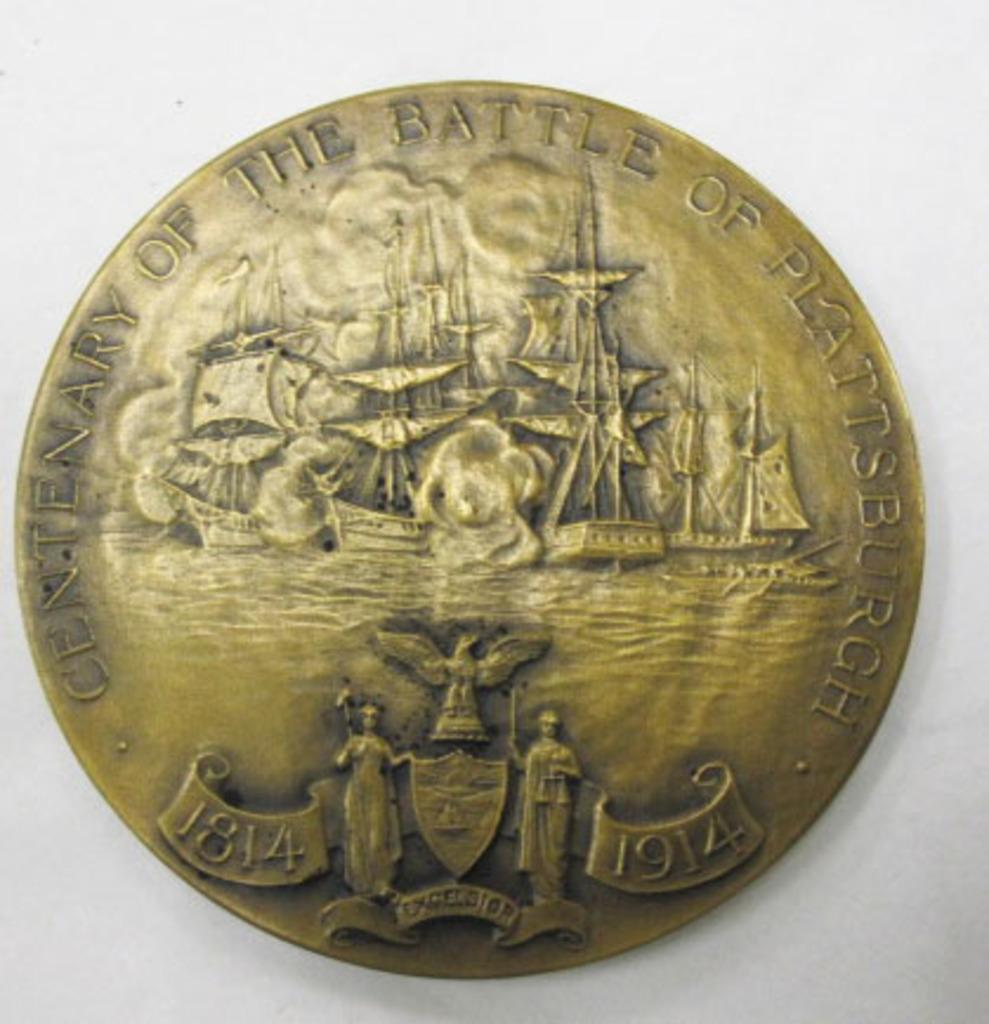<image>
Render a clear and concise summary of the photo. a gold coin that says 'centenary of the battle of plattsburgh' 1914 and 1814 